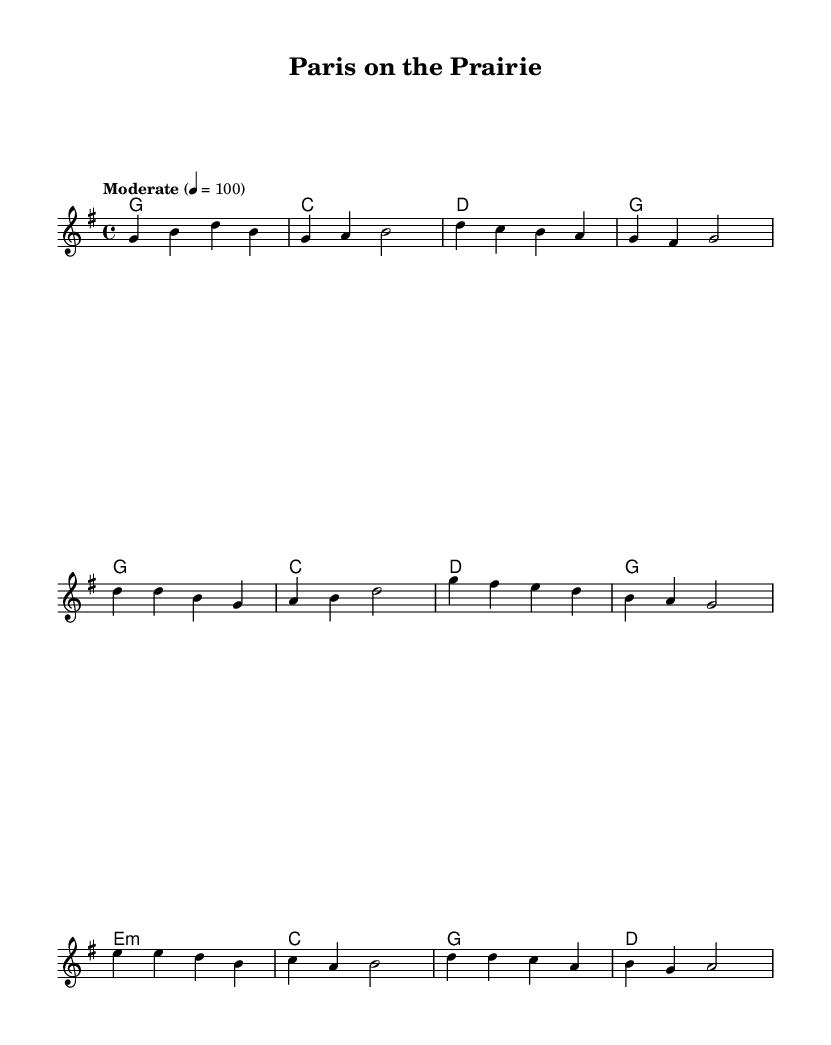What is the key signature of this music? The key signature is G major, which has one sharp (F#). This can be identified in the global settings at the top of the code where it's specified "\key g \major".
Answer: G major What is the time signature of this music? The time signature is 4/4, indicating four beats in a measure. This is indicated in the global settings with "\time 4/4".
Answer: 4/4 What is the tempo marking for this piece? The tempo marking is "Moderate" at a speed of 100 beats per minute. This is defined in the global section with "\tempo 'Moderate' 4 = 100".
Answer: Moderate How many sections does this piece have? The song is structured into three distinct sections: Verse, Chorus, and Bridge. This can be deduced from the named sections included in the melody and lyrics.
Answer: 3 What type of chord is played in the Bridge? The chord played in the Bridge is E minor, indicated by "e1:m" in the harmonies section of the code.
Answer: E minor What is the lyrical theme of the Chorus? The chorus reflects a blend of French culture with country style, highlighting a romantic scenery, as indicated by the words "Pa -- ris on the prai -- rie, where French meets coun -- try style." This embodies the song's theme of merging these cultures.
Answer: Merge of cultures What instrument is most likely featured in this piece? This piece is written for a traditional staff, which is commonly associated with instruments like guitar or piano in country music. The chord names indicate accompaniment typical for these instruments.
Answer: Guitar or piano 